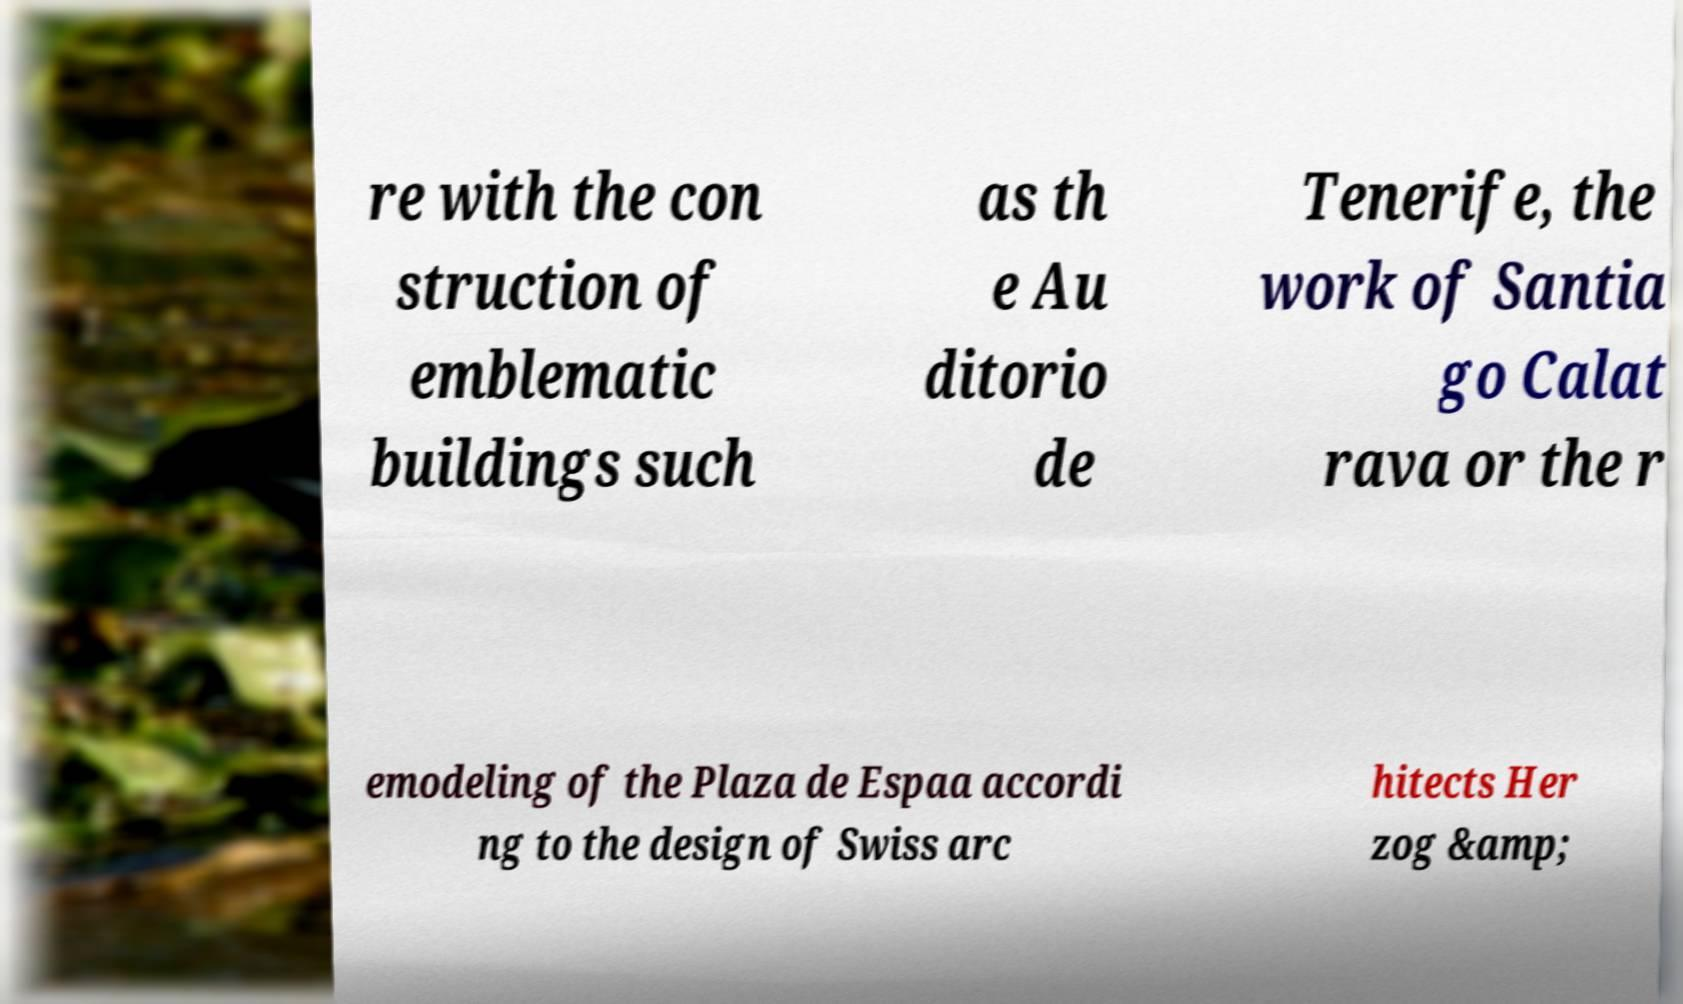Could you extract and type out the text from this image? re with the con struction of emblematic buildings such as th e Au ditorio de Tenerife, the work of Santia go Calat rava or the r emodeling of the Plaza de Espaa accordi ng to the design of Swiss arc hitects Her zog &amp; 